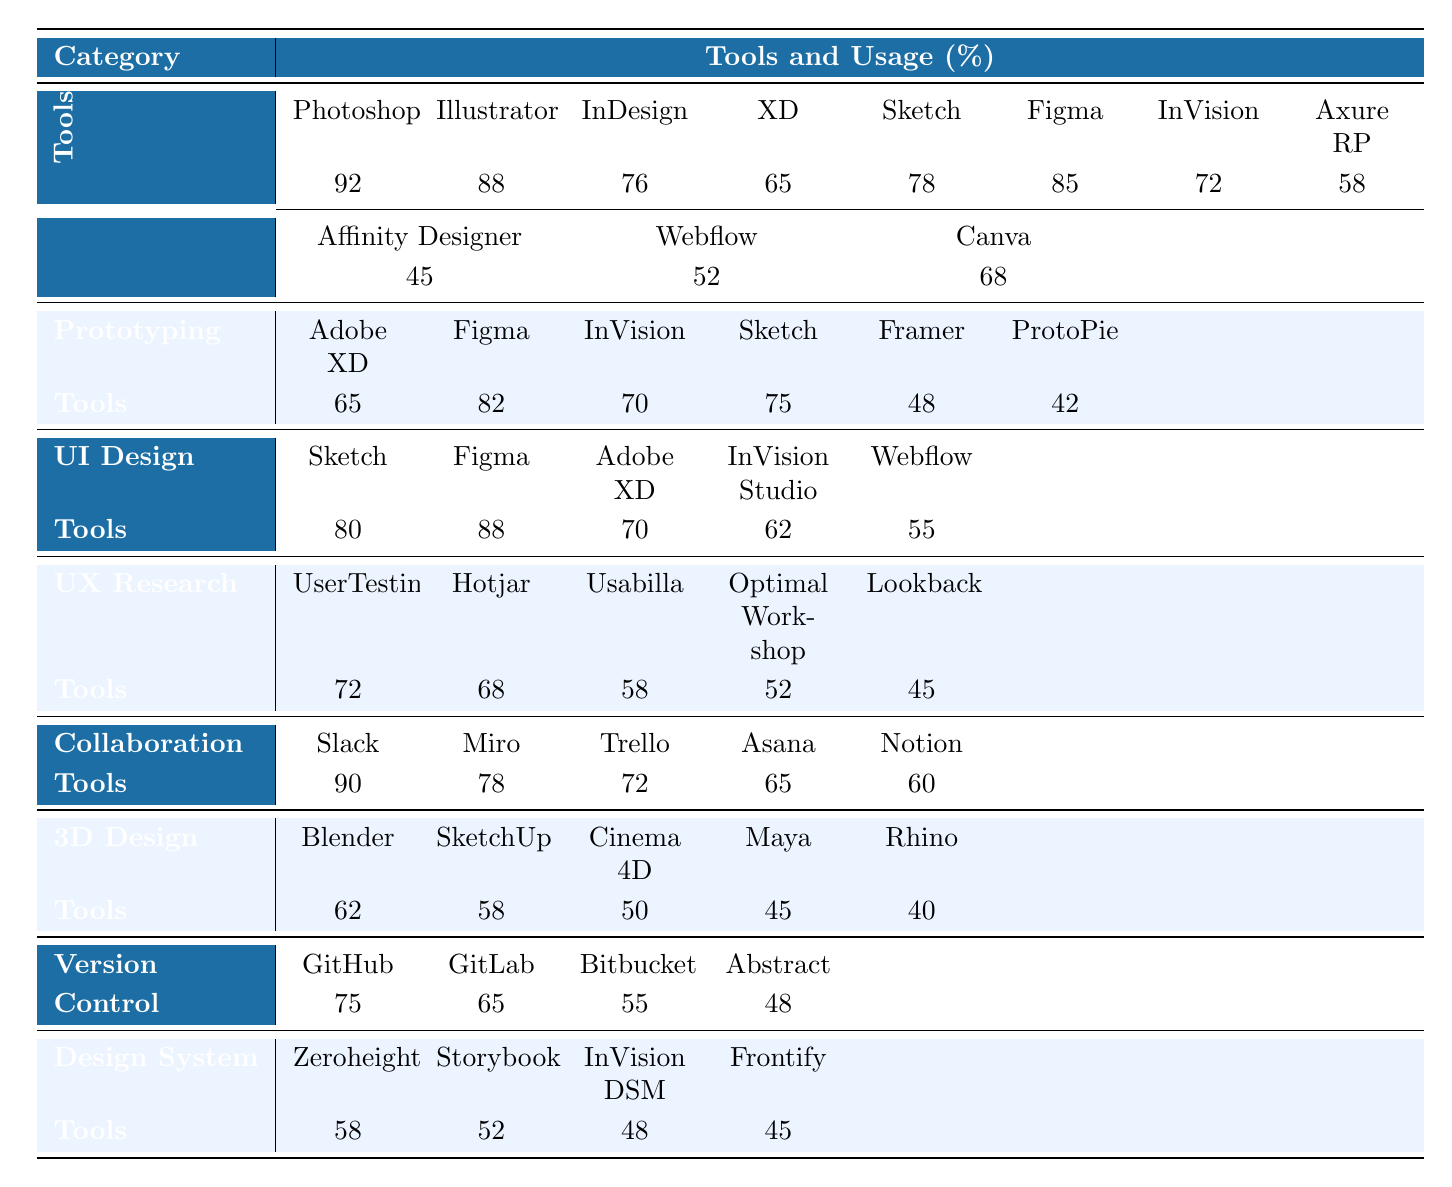What is the highest rated tool in the Design Tools category? The highest rated tool in the Design Tools category is Photoshop, which has a usage percentage of 92.
Answer: Photoshop Which prototyping tool has the lowest usage percentage? From the Prototyping Tools category, ProtoPie has the lowest usage percentage at 42.
Answer: ProtoPie What are the usage percentages for Figma in UI Design Tools and Prototyping Tools? In UI Design Tools, Figma has a usage percentage of 88, and in Prototyping Tools, it has a usage percentage of 82.
Answer: 88 and 82 Is Slack the most popular collaboration tool? Yes, Slack has a usage percentage of 90, making it the most popular collaboration tool according to the data.
Answer: Yes What percentage difference is there between the usage of GitHub and GitLab in Version Control? GitHub has a usage percentage of 75, and GitLab has 65. The difference is 75 - 65 = 10.
Answer: 10 Which category has the tool with the highest rating, and what is that rating? The Design Tools category has the highest rating tool, which is Photoshop at 92.
Answer: Design Tools, 92 Among the 3D Design Tools, which tool has the highest usage percentage? Blender has the highest usage percentage among the 3D Design Tools at 62.
Answer: Blender What is the average usage percentage of the tools listed under UX Research Tools? Adding the percentages: 72 + 68 + 58 + 52 + 45 = 295; there are 5 tools, so the average is 295/5 = 59.
Answer: 59 Are there any Design System Tools with usage percentages below 50? Yes, the tools in the Design System Tools category (InVision DSM and Frontify) have usage percentages below 50 (48 and 45).
Answer: Yes Which UI Design Tool has a usage percentage of 70? Adobe XD has a usage percentage of 70 in the UI Design Tools category.
Answer: Adobe XD 